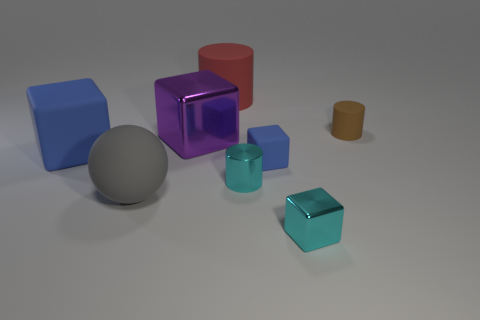Can you tell which object stands out the most? The object that stands out the most is the purple cube due to its unique color and reflective surface which contrasts with the more matte appearances of the other objects. What does that tell us about the object or the lighting in the scene? This suggests that the object may be made of a different material, possibly glass or a highly polished metal, which is causing it to reflect more light and appear more vivid compared to the other objects. Additionally, the lighting setup might be positioned to particularly highlight this object. 